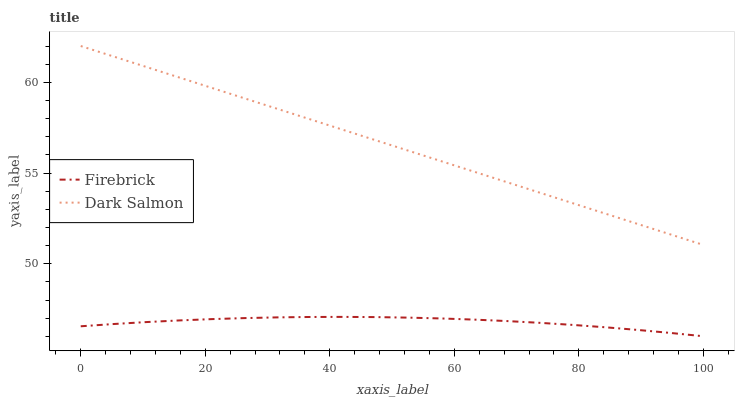Does Firebrick have the minimum area under the curve?
Answer yes or no. Yes. Does Dark Salmon have the maximum area under the curve?
Answer yes or no. Yes. Does Dark Salmon have the minimum area under the curve?
Answer yes or no. No. Is Dark Salmon the smoothest?
Answer yes or no. Yes. Is Firebrick the roughest?
Answer yes or no. Yes. Is Dark Salmon the roughest?
Answer yes or no. No. Does Firebrick have the lowest value?
Answer yes or no. Yes. Does Dark Salmon have the lowest value?
Answer yes or no. No. Does Dark Salmon have the highest value?
Answer yes or no. Yes. Is Firebrick less than Dark Salmon?
Answer yes or no. Yes. Is Dark Salmon greater than Firebrick?
Answer yes or no. Yes. Does Firebrick intersect Dark Salmon?
Answer yes or no. No. 